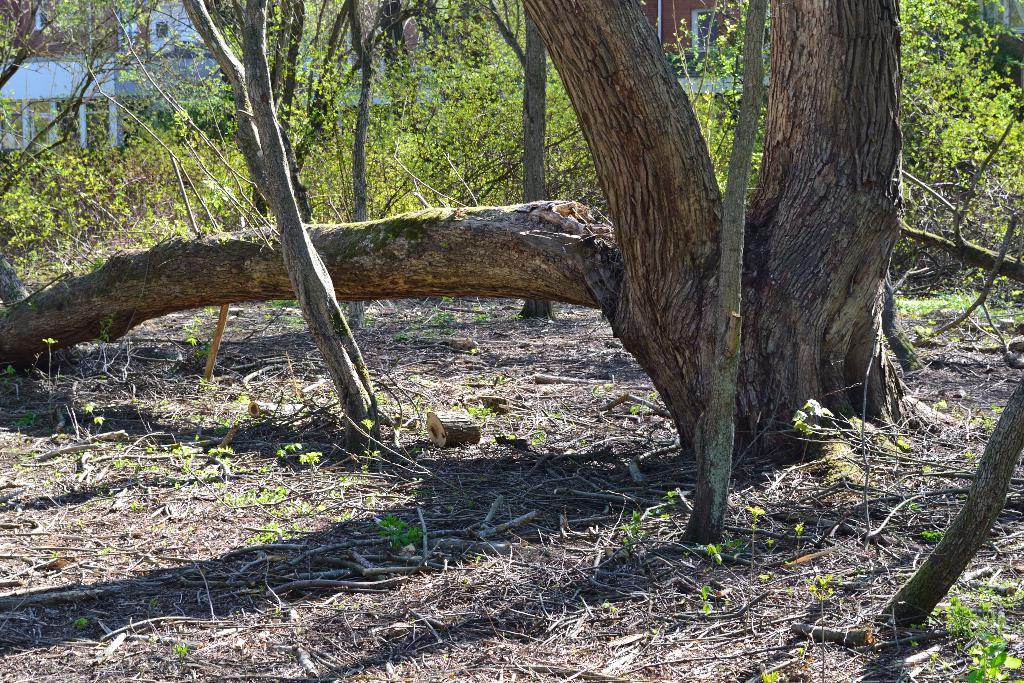What is located on the right side of the image? There is a tree trunk on the right side of the image. What is the condition of the tree trunk? The tree trunk appears to be broken. Where is the broken tree trunk situated? The broken tree trunk is on the ground. What can be seen in the distance in the image? There are buildings and trees visible in the background of the image. How many pizzas are hanging from the broken tree trunk in the image? There are no pizzas present in the image; it features a broken tree trunk on the ground. 